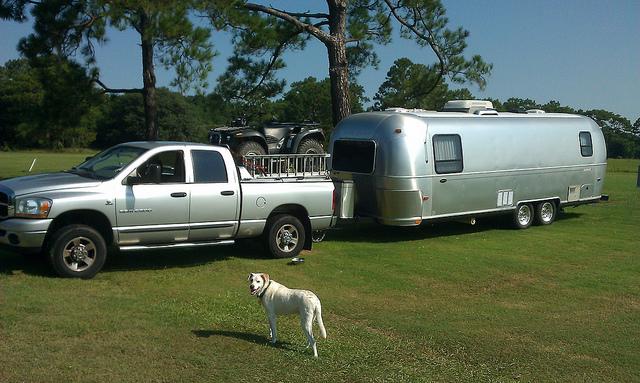Are the pickup and the trailer the same color?
Answer briefly. Yes. Is the trailer big enough for people to sleep in?
Short answer required. Yes. Is the dog in the truck?
Be succinct. No. What vehicle is in the truck bed?
Write a very short answer. Atv. 